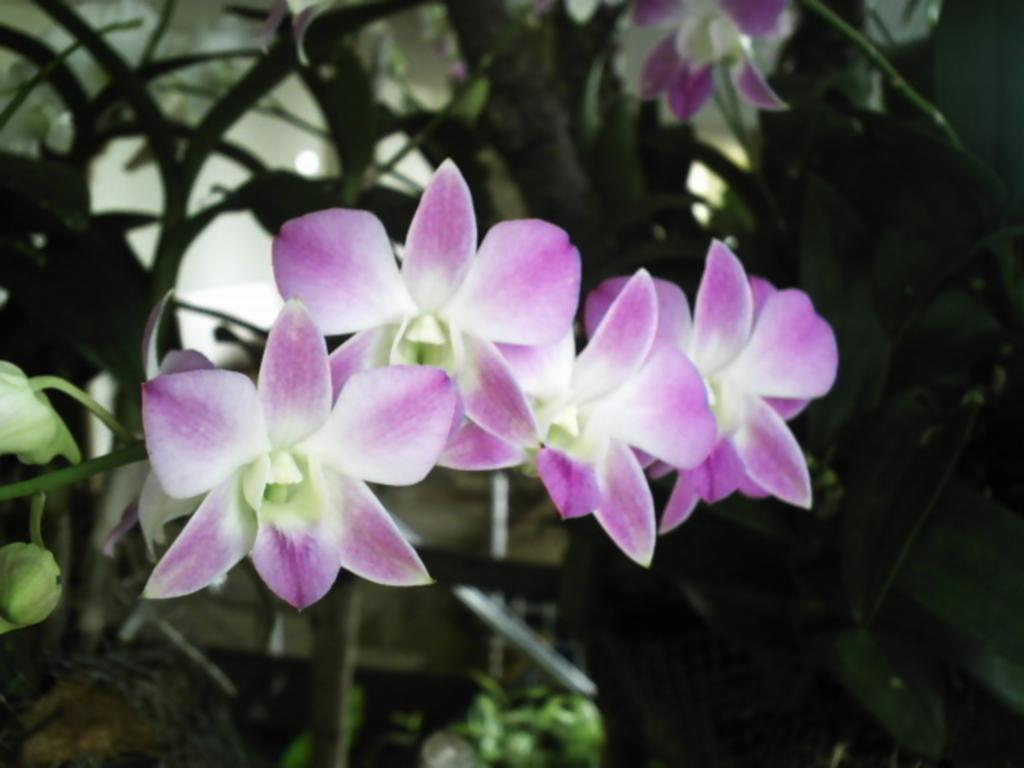Where was the image taken? The image was taken outdoors. What can be seen in the image besides the outdoor setting? There are plants in the image. Can you describe the plants in the image? The plants have leaves, stems, and flowers. What color are the flowers on the plants? The flowers are lilac in color. How many ducks are swimming in the lilac flowers in the image? There are no ducks present in the image, and the flowers are not depicted as a body of water for ducks to swim in. 